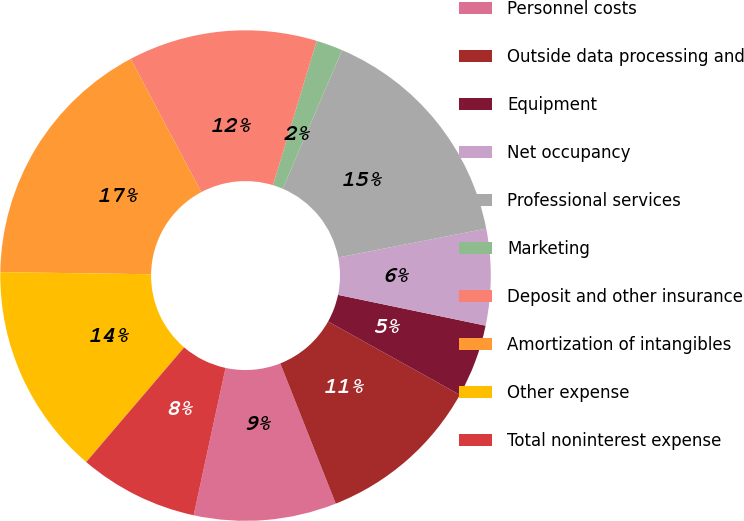Convert chart. <chart><loc_0><loc_0><loc_500><loc_500><pie_chart><fcel>Personnel costs<fcel>Outside data processing and<fcel>Equipment<fcel>Net occupancy<fcel>Professional services<fcel>Marketing<fcel>Deposit and other insurance<fcel>Amortization of intangibles<fcel>Other expense<fcel>Total noninterest expense<nl><fcel>9.39%<fcel>10.92%<fcel>4.81%<fcel>6.34%<fcel>15.49%<fcel>1.76%<fcel>12.44%<fcel>17.02%<fcel>13.97%<fcel>7.86%<nl></chart> 